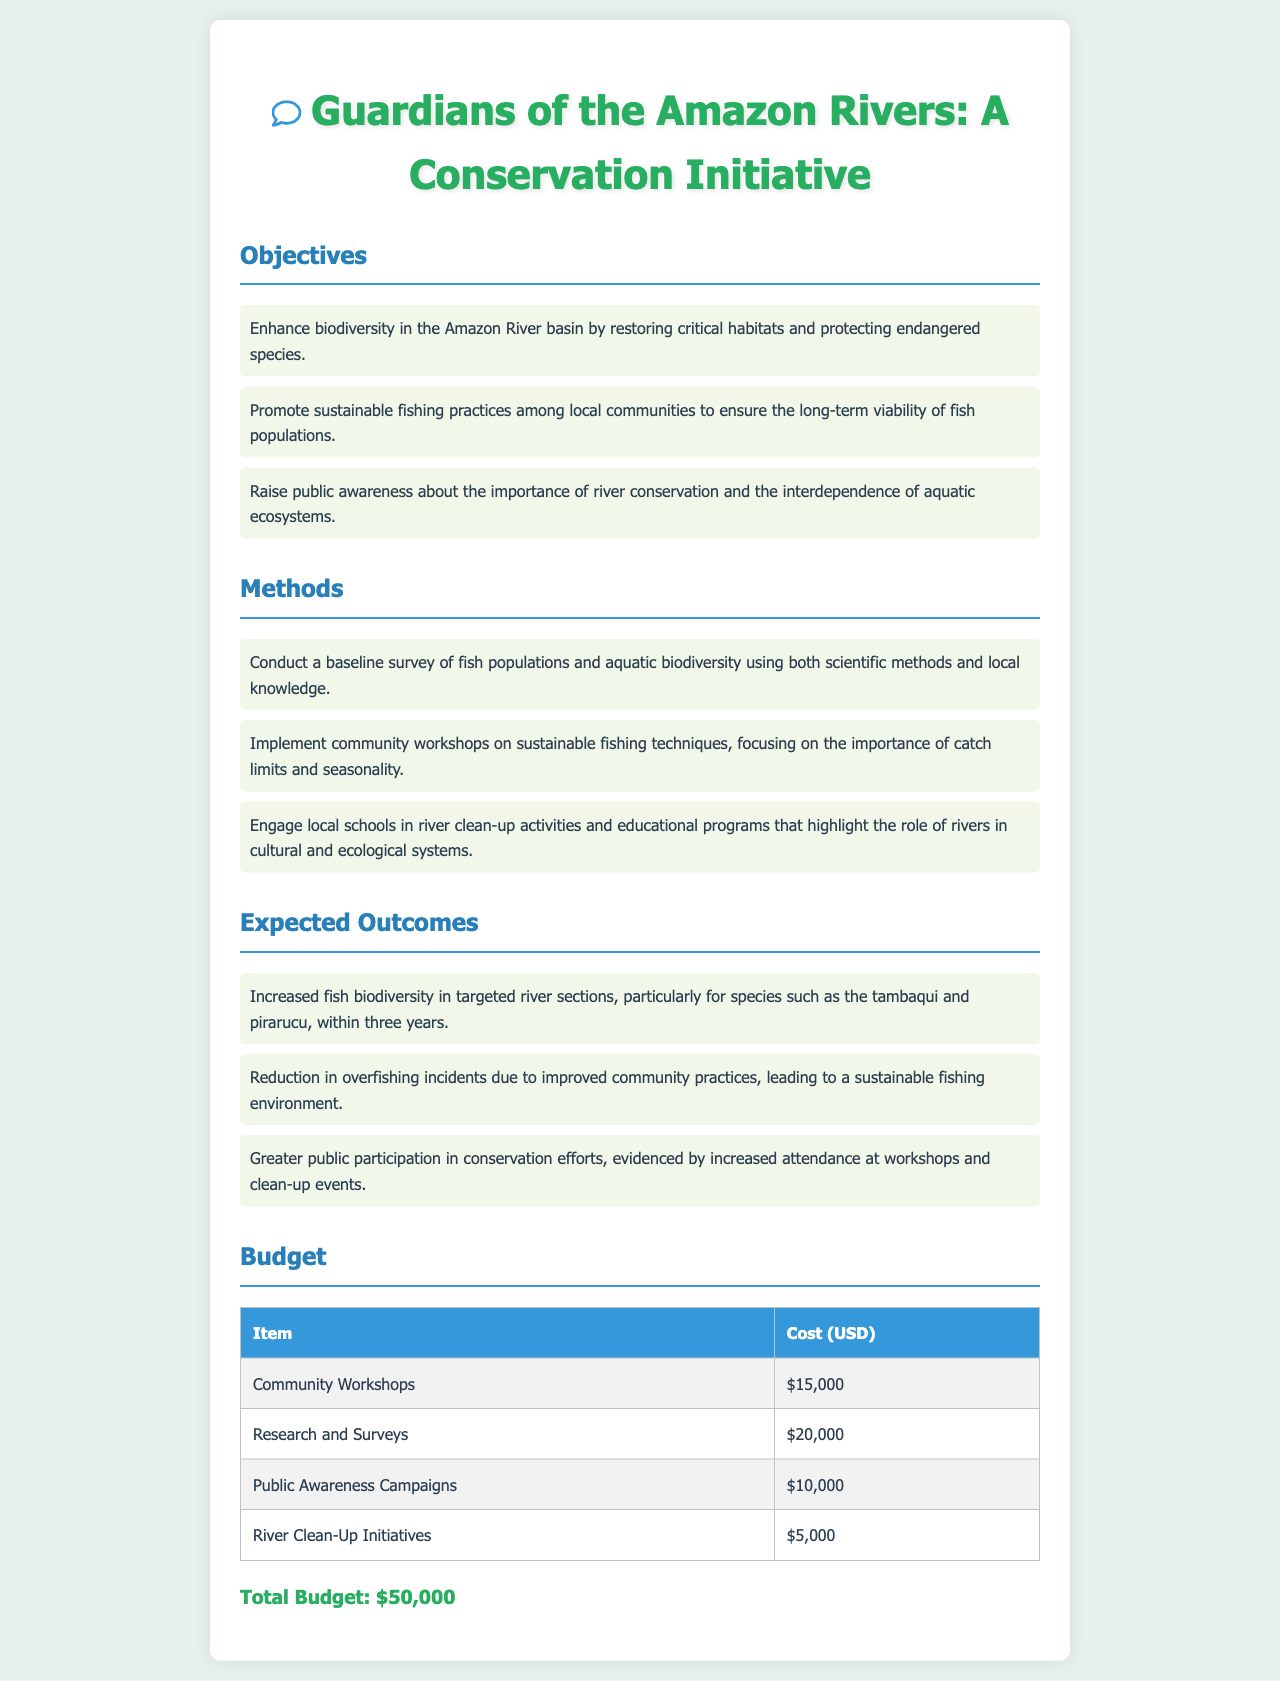What is the title of the proposal? The title is clearly stated at the top of the document as part of the main heading.
Answer: Guardians of the Amazon Rivers: A Conservation Initiative How many objectives are listed? The number of objectives is indicated by counting the items in the corresponding section.
Answer: Three What is the budget for Community Workshops? The budget is specifically mentioned in the budget table under the item "Community Workshops."
Answer: $15,000 Which species is mentioned as part of the expected outcomes? The species is noted as a key focus in the expected outcomes section regarding biodiversity.
Answer: Tambaqui What is the total budget of the project? The total budget is summarized at the end of the budget table, giving a total for all listed expenses.
Answer: $50,000 Which method focuses on local schools? The document explicitly mentions engaging local schools as part of one of the methods used in the conservation initiative.
Answer: River clean-up activities What is one expected outcome related to overfishing? This outcome is clearly stated in the expected outcomes section, addressing the issue of community fishing practices.
Answer: Reduction in overfishing incidents What type of initiatives does the budget include? The budget table lists various initiatives and their respective costs, focusing on community involvement and research.
Answer: Community Workshops How much funding is allocated for Public Awareness Campaigns? This information can be found in the budget table under the item for public awareness.
Answer: $10,000 